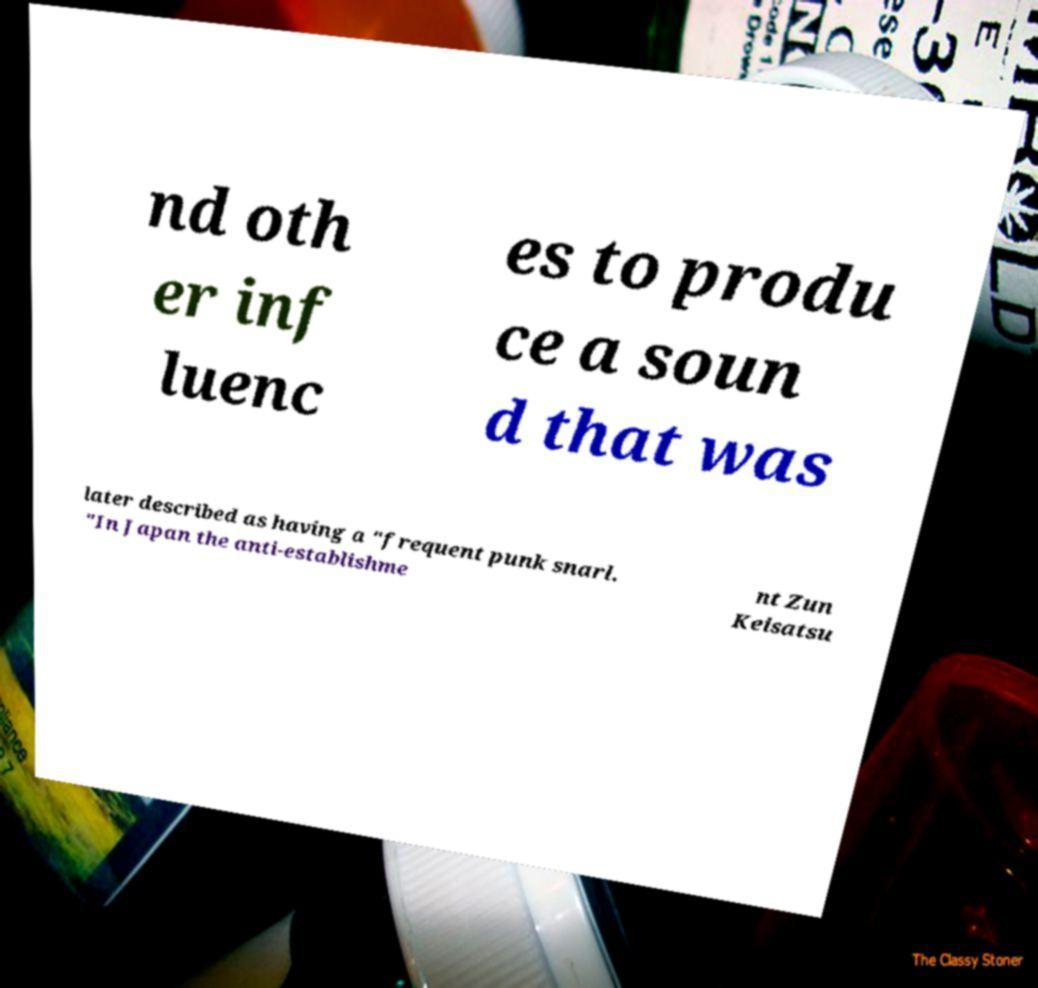Please identify and transcribe the text found in this image. nd oth er inf luenc es to produ ce a soun d that was later described as having a "frequent punk snarl. "In Japan the anti-establishme nt Zun Keisatsu 